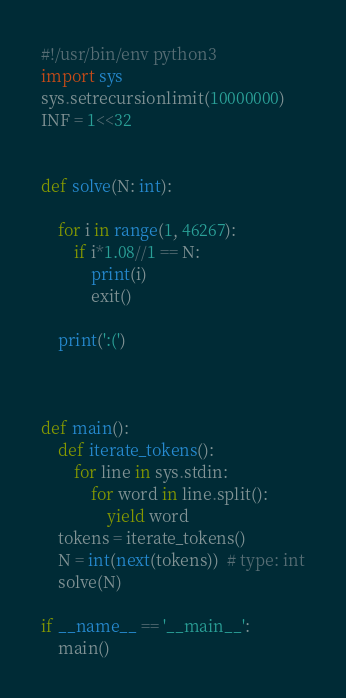Convert code to text. <code><loc_0><loc_0><loc_500><loc_500><_Python_>#!/usr/bin/env python3
import sys
sys.setrecursionlimit(10000000)
INF = 1<<32


def solve(N: int):
    
    for i in range(1, 46267):
        if i*1.08//1 == N:
            print(i)
            exit()
        
    print(':(')



def main():
    def iterate_tokens():
        for line in sys.stdin:
            for word in line.split():
                yield word
    tokens = iterate_tokens()
    N = int(next(tokens))  # type: int
    solve(N)

if __name__ == '__main__':
    main()
</code> 